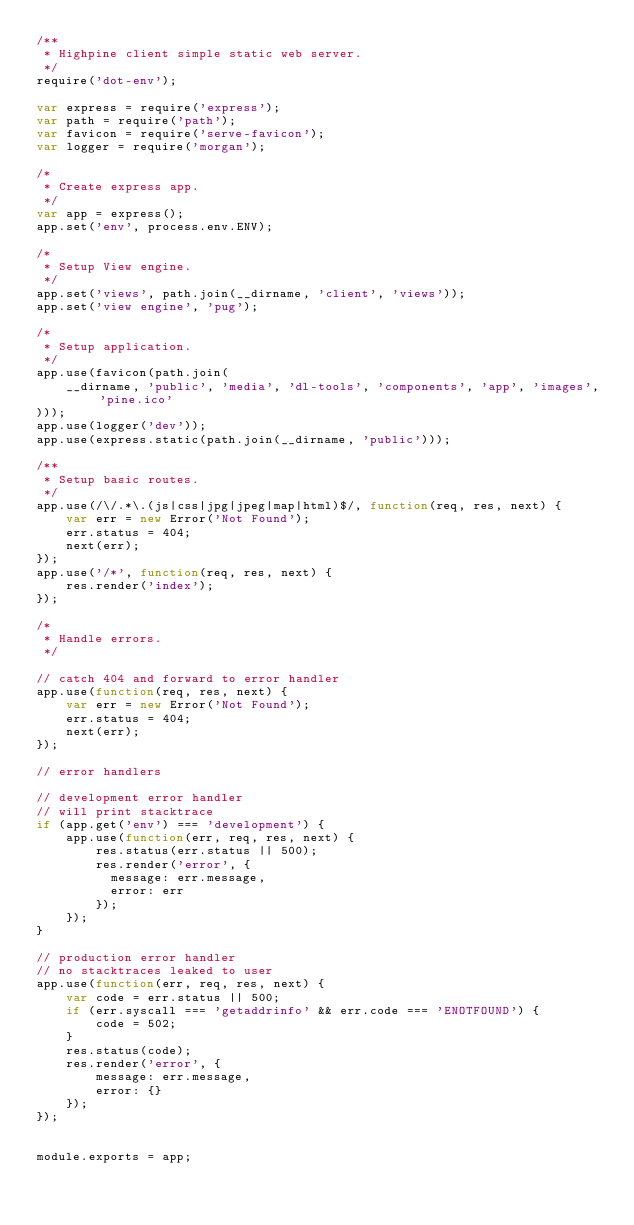<code> <loc_0><loc_0><loc_500><loc_500><_JavaScript_>/**
 * Highpine client simple static web server.
 */
require('dot-env');

var express = require('express');
var path = require('path');
var favicon = require('serve-favicon');
var logger = require('morgan');

/*
 * Create express app.
 */
var app = express();
app.set('env', process.env.ENV);

/*
 * Setup View engine.
 */
app.set('views', path.join(__dirname, 'client', 'views'));
app.set('view engine', 'pug');

/*
 * Setup application.
 */
app.use(favicon(path.join(
    __dirname, 'public', 'media', 'dl-tools', 'components', 'app', 'images', 'pine.ico'
)));
app.use(logger('dev'));
app.use(express.static(path.join(__dirname, 'public')));

/**
 * Setup basic routes.
 */
app.use(/\/.*\.(js|css|jpg|jpeg|map|html)$/, function(req, res, next) {
    var err = new Error('Not Found');
    err.status = 404;
    next(err);
});
app.use('/*', function(req, res, next) {
    res.render('index');
});

/*
 * Handle errors.
 */

// catch 404 and forward to error handler
app.use(function(req, res, next) {
    var err = new Error('Not Found');
    err.status = 404;
    next(err);
});

// error handlers

// development error handler
// will print stacktrace
if (app.get('env') === 'development') {
    app.use(function(err, req, res, next) {
        res.status(err.status || 500);
        res.render('error', {
          message: err.message,
          error: err
        });
    });
}

// production error handler
// no stacktraces leaked to user
app.use(function(err, req, res, next) {
    var code = err.status || 500;
    if (err.syscall === 'getaddrinfo' && err.code === 'ENOTFOUND') {
        code = 502;
    }
    res.status(code);
    res.render('error', {
        message: err.message,
        error: {}
    });
});


module.exports = app;
</code> 